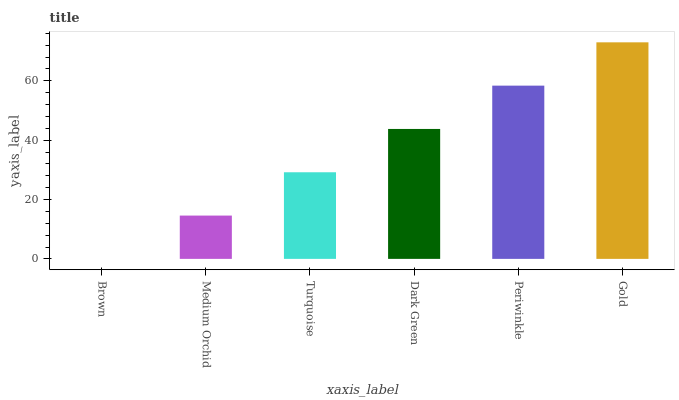Is Brown the minimum?
Answer yes or no. Yes. Is Gold the maximum?
Answer yes or no. Yes. Is Medium Orchid the minimum?
Answer yes or no. No. Is Medium Orchid the maximum?
Answer yes or no. No. Is Medium Orchid greater than Brown?
Answer yes or no. Yes. Is Brown less than Medium Orchid?
Answer yes or no. Yes. Is Brown greater than Medium Orchid?
Answer yes or no. No. Is Medium Orchid less than Brown?
Answer yes or no. No. Is Dark Green the high median?
Answer yes or no. Yes. Is Turquoise the low median?
Answer yes or no. Yes. Is Gold the high median?
Answer yes or no. No. Is Gold the low median?
Answer yes or no. No. 